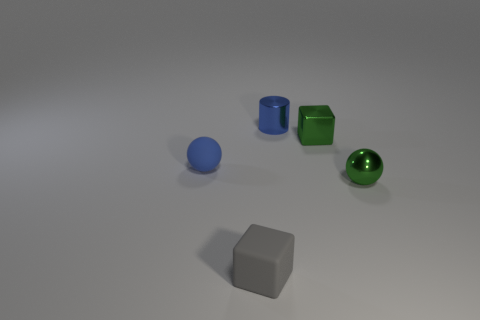There is a small object that is in front of the matte ball and behind the gray thing; what is its material?
Keep it short and to the point. Metal. What is the shape of the tiny blue object that is the same material as the green block?
Your answer should be very brief. Cylinder. There is a matte object that is behind the tiny green sphere; how many rubber spheres are behind it?
Offer a terse response. 0. How many small objects are both in front of the blue matte sphere and to the left of the small green block?
Your answer should be compact. 1. How many other things are the same material as the blue cylinder?
Your answer should be compact. 2. There is a ball that is to the right of the small green block on the left side of the small shiny sphere; what is its color?
Keep it short and to the point. Green. Do the tiny sphere that is behind the green metallic sphere and the shiny cylinder have the same color?
Give a very brief answer. Yes. Is the blue metal cylinder the same size as the green shiny sphere?
Provide a short and direct response. Yes. What shape is the blue object that is the same size as the blue cylinder?
Your answer should be very brief. Sphere. There is a green metallic object in front of the green cube; does it have the same size as the small gray object?
Make the answer very short. Yes. 